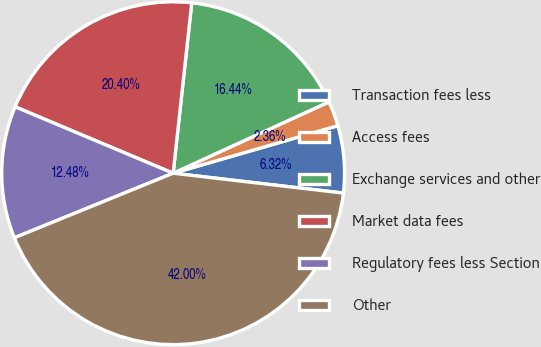Convert chart to OTSL. <chart><loc_0><loc_0><loc_500><loc_500><pie_chart><fcel>Transaction fees less<fcel>Access fees<fcel>Exchange services and other<fcel>Market data fees<fcel>Regulatory fees less Section<fcel>Other<nl><fcel>6.32%<fcel>2.36%<fcel>16.44%<fcel>20.4%<fcel>12.48%<fcel>42.0%<nl></chart> 